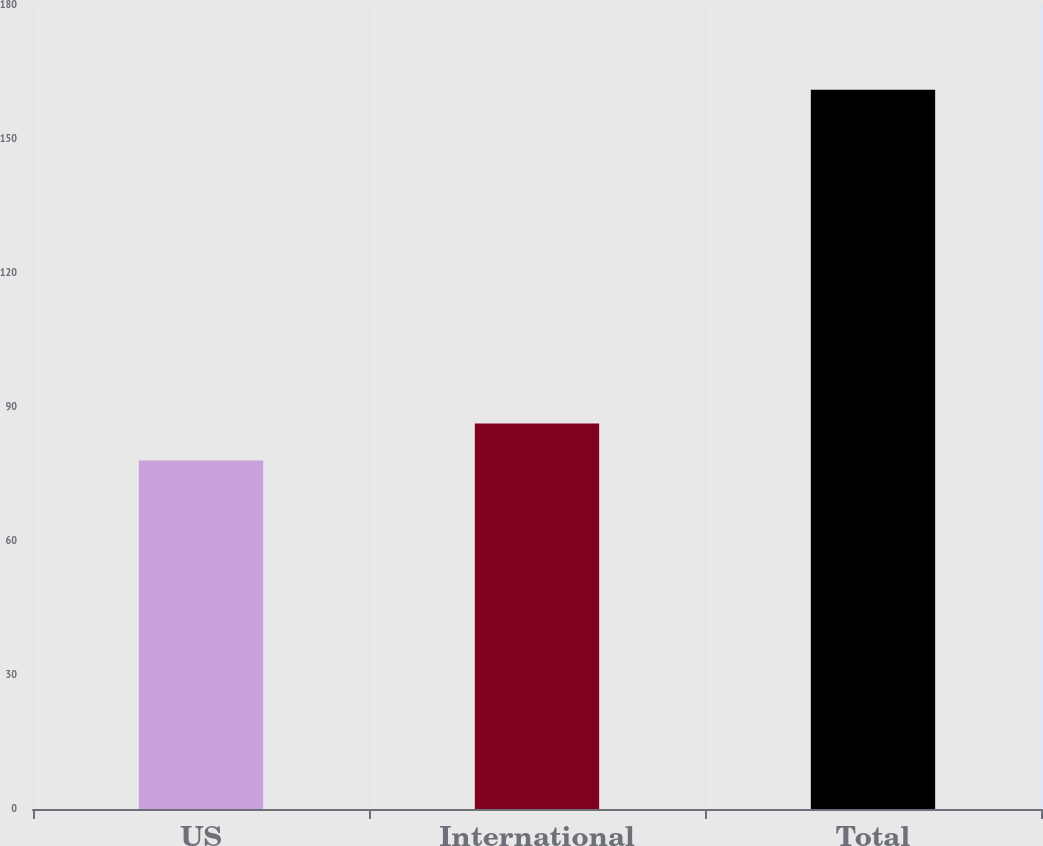Convert chart to OTSL. <chart><loc_0><loc_0><loc_500><loc_500><bar_chart><fcel>US<fcel>International<fcel>Total<nl><fcel>78<fcel>86.3<fcel>161<nl></chart> 